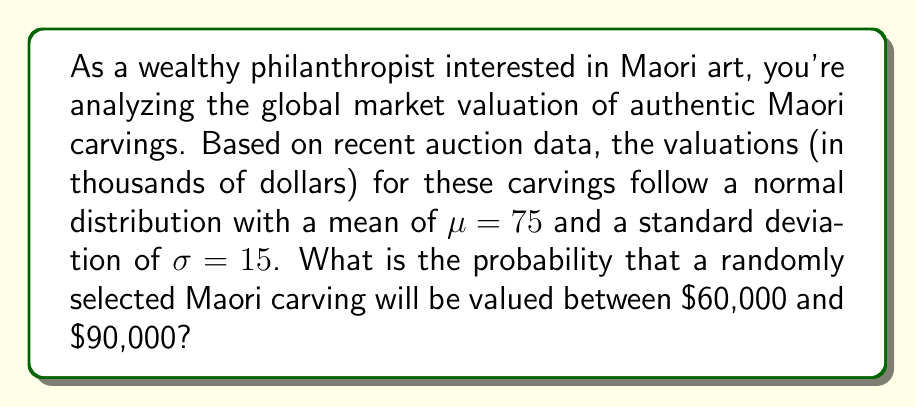Give your solution to this math problem. To solve this problem, we need to use the properties of the normal distribution and the concept of z-scores.

1) First, let's calculate the z-scores for the lower and upper bounds of our range:

   For $60,000: z_1 = \frac{60 - 75}{15} = -1$
   For $90,000: z_2 = \frac{90 - 75}{15} = 1$

2) Now, we need to find the area under the standard normal curve between these two z-scores. This can be done using the standard normal cumulative distribution function (CDF), which we'll denote as $\Phi(z)$.

3) The probability we're looking for is:

   $P(60 < X < 90) = \Phi(z_2) - \Phi(z_1) = \Phi(1) - \Phi(-1)$

4) From standard normal distribution tables or using a calculator:

   $\Phi(1) \approx 0.8413$
   $\Phi(-1) = 1 - \Phi(1) \approx 0.1587$

5) Therefore, the probability is:

   $P(60 < X < 90) = 0.8413 - 0.1587 = 0.6826$

This means there's approximately a 68.26% chance that a randomly selected Maori carving will be valued between $60,000 and $90,000.
Answer: The probability that a randomly selected Maori carving will be valued between $60,000 and $90,000 is approximately 0.6826 or 68.26%. 